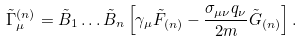<formula> <loc_0><loc_0><loc_500><loc_500>\tilde { \Gamma } _ { \mu } ^ { ( n ) } = \tilde { B } _ { 1 } \dots \tilde { B } _ { n } \left [ \gamma _ { \mu } \tilde { F } _ { ( n ) } - \frac { \sigma _ { \mu \nu } q _ { \nu } } { 2 m } \tilde { G } _ { ( n ) } \right ] .</formula> 